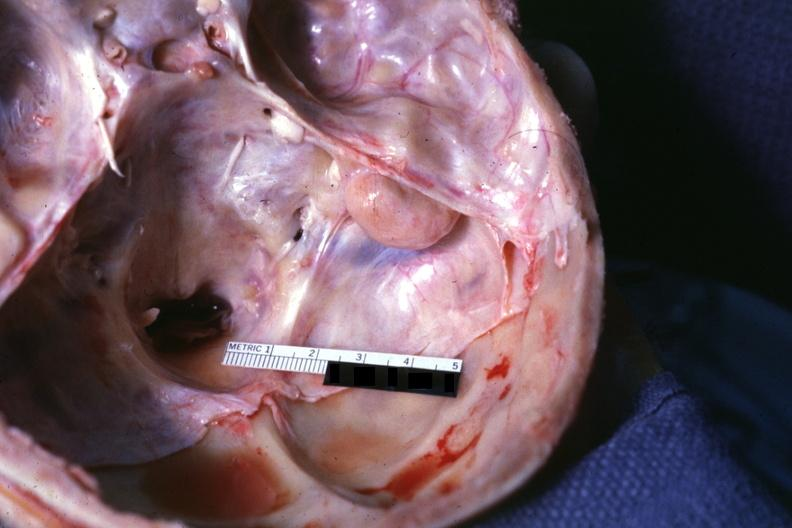s gastrointestinal present?
Answer the question using a single word or phrase. No 